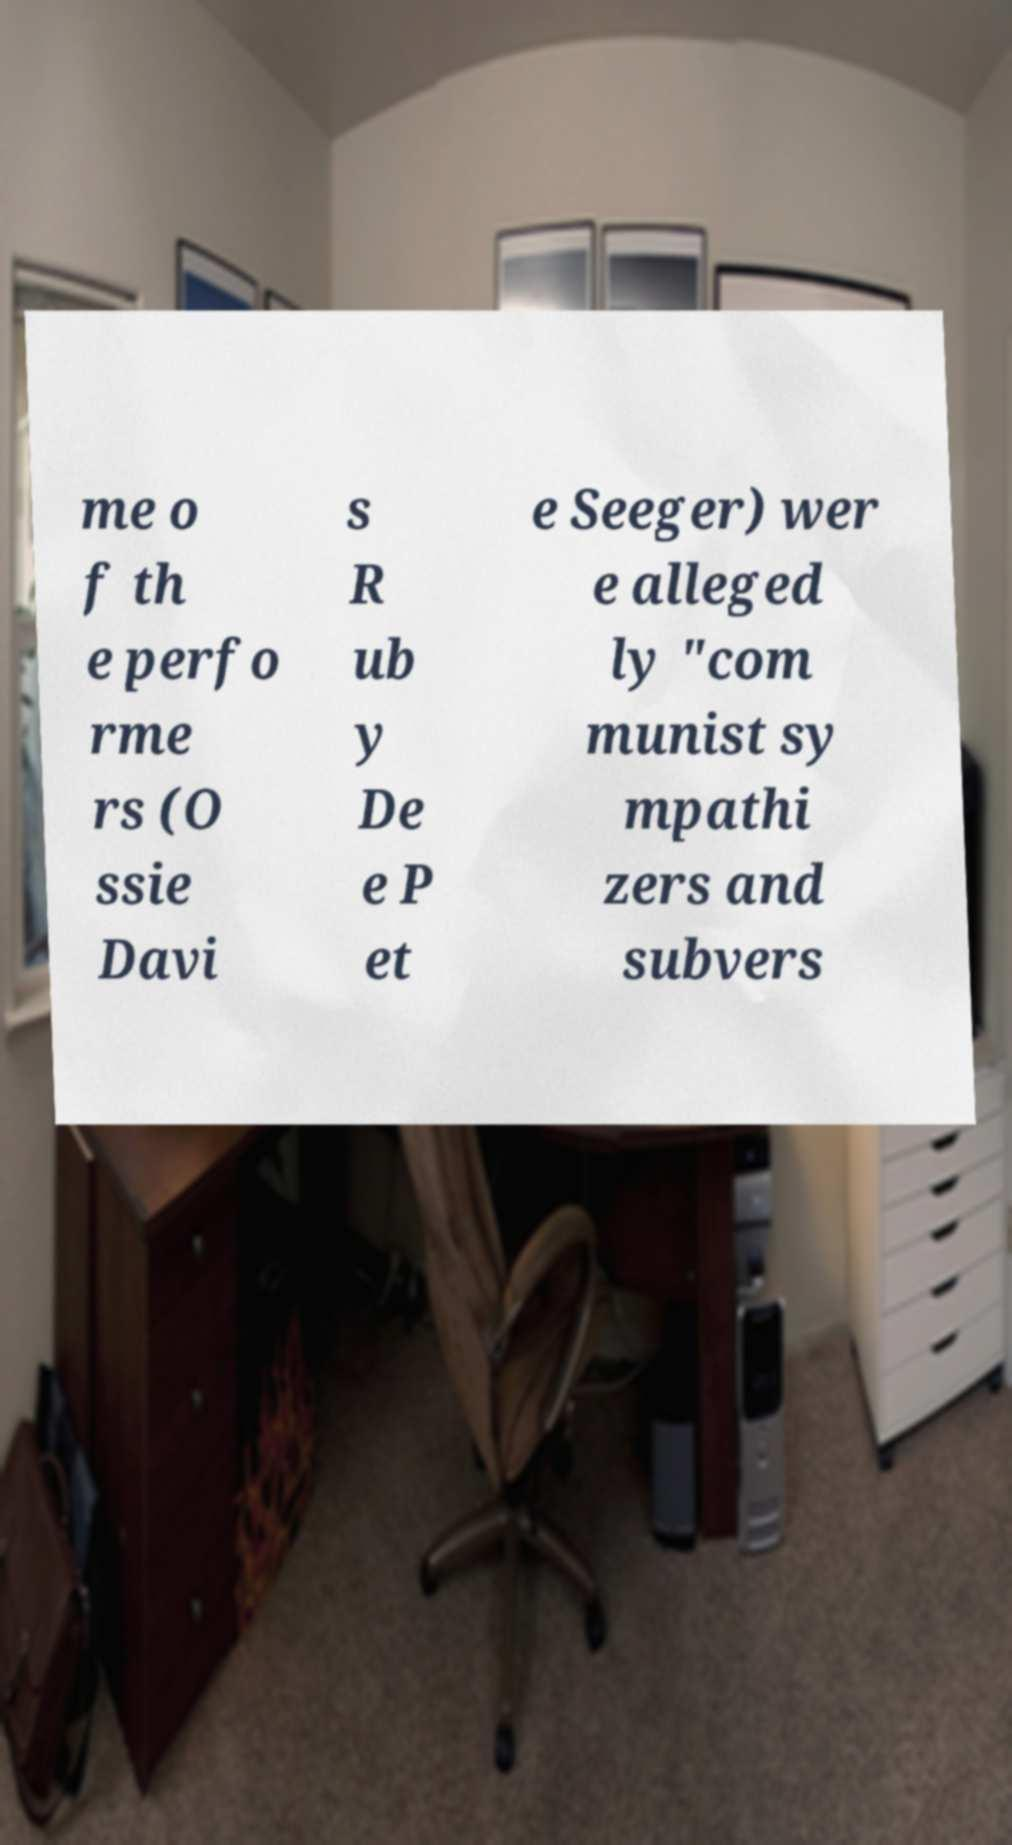How might this document have been used in a historical context? This document appears to be part of a broader discourse on McCarthyism and the Red Scare in the United States, where individuals were frequently accused of being communist sympathizers, which often resulted in public trials and blacklisting. Documents like these could have been used as evidence or to stoke public fear about Communism infiltrating American society. 